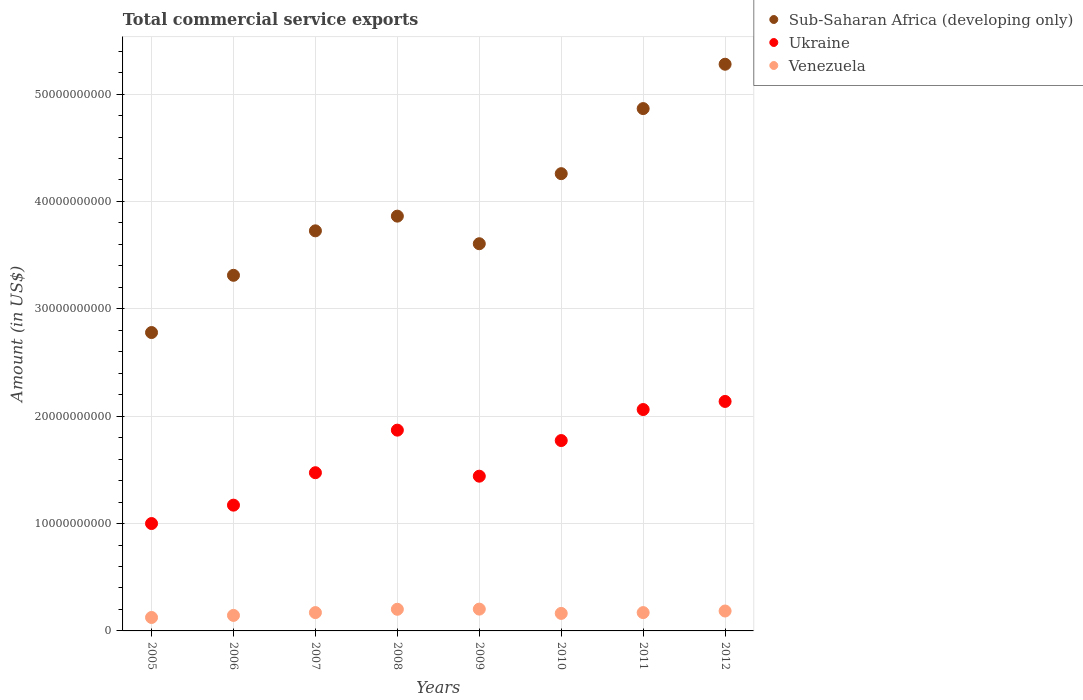What is the total commercial service exports in Sub-Saharan Africa (developing only) in 2011?
Your answer should be very brief. 4.86e+1. Across all years, what is the maximum total commercial service exports in Ukraine?
Keep it short and to the point. 2.14e+1. Across all years, what is the minimum total commercial service exports in Sub-Saharan Africa (developing only)?
Your response must be concise. 2.78e+1. In which year was the total commercial service exports in Venezuela minimum?
Give a very brief answer. 2005. What is the total total commercial service exports in Sub-Saharan Africa (developing only) in the graph?
Provide a succinct answer. 3.17e+11. What is the difference between the total commercial service exports in Ukraine in 2008 and that in 2011?
Your answer should be very brief. -1.92e+09. What is the difference between the total commercial service exports in Venezuela in 2011 and the total commercial service exports in Sub-Saharan Africa (developing only) in 2012?
Provide a succinct answer. -5.11e+1. What is the average total commercial service exports in Sub-Saharan Africa (developing only) per year?
Provide a short and direct response. 3.96e+1. In the year 2007, what is the difference between the total commercial service exports in Sub-Saharan Africa (developing only) and total commercial service exports in Venezuela?
Keep it short and to the point. 3.56e+1. In how many years, is the total commercial service exports in Ukraine greater than 40000000000 US$?
Keep it short and to the point. 0. What is the ratio of the total commercial service exports in Sub-Saharan Africa (developing only) in 2007 to that in 2009?
Your answer should be very brief. 1.03. Is the difference between the total commercial service exports in Sub-Saharan Africa (developing only) in 2006 and 2010 greater than the difference between the total commercial service exports in Venezuela in 2006 and 2010?
Provide a short and direct response. No. What is the difference between the highest and the second highest total commercial service exports in Sub-Saharan Africa (developing only)?
Ensure brevity in your answer.  4.13e+09. What is the difference between the highest and the lowest total commercial service exports in Sub-Saharan Africa (developing only)?
Provide a succinct answer. 2.50e+1. Is the total commercial service exports in Venezuela strictly less than the total commercial service exports in Sub-Saharan Africa (developing only) over the years?
Provide a short and direct response. Yes. How many dotlines are there?
Your answer should be very brief. 3. Are the values on the major ticks of Y-axis written in scientific E-notation?
Provide a succinct answer. No. Does the graph contain any zero values?
Ensure brevity in your answer.  No. Does the graph contain grids?
Offer a terse response. Yes. Where does the legend appear in the graph?
Your answer should be very brief. Top right. How are the legend labels stacked?
Make the answer very short. Vertical. What is the title of the graph?
Give a very brief answer. Total commercial service exports. Does "Eritrea" appear as one of the legend labels in the graph?
Keep it short and to the point. No. What is the label or title of the X-axis?
Your response must be concise. Years. What is the Amount (in US$) of Sub-Saharan Africa (developing only) in 2005?
Provide a succinct answer. 2.78e+1. What is the Amount (in US$) of Ukraine in 2005?
Ensure brevity in your answer.  1.00e+1. What is the Amount (in US$) in Venezuela in 2005?
Offer a terse response. 1.25e+09. What is the Amount (in US$) in Sub-Saharan Africa (developing only) in 2006?
Your answer should be compact. 3.31e+1. What is the Amount (in US$) of Ukraine in 2006?
Provide a succinct answer. 1.17e+1. What is the Amount (in US$) in Venezuela in 2006?
Give a very brief answer. 1.44e+09. What is the Amount (in US$) in Sub-Saharan Africa (developing only) in 2007?
Keep it short and to the point. 3.73e+1. What is the Amount (in US$) of Ukraine in 2007?
Your answer should be very brief. 1.47e+1. What is the Amount (in US$) of Venezuela in 2007?
Make the answer very short. 1.71e+09. What is the Amount (in US$) in Sub-Saharan Africa (developing only) in 2008?
Offer a very short reply. 3.86e+1. What is the Amount (in US$) in Ukraine in 2008?
Make the answer very short. 1.87e+1. What is the Amount (in US$) in Venezuela in 2008?
Make the answer very short. 2.02e+09. What is the Amount (in US$) of Sub-Saharan Africa (developing only) in 2009?
Your answer should be very brief. 3.61e+1. What is the Amount (in US$) in Ukraine in 2009?
Provide a short and direct response. 1.44e+1. What is the Amount (in US$) in Venezuela in 2009?
Keep it short and to the point. 2.03e+09. What is the Amount (in US$) in Sub-Saharan Africa (developing only) in 2010?
Ensure brevity in your answer.  4.26e+1. What is the Amount (in US$) in Ukraine in 2010?
Provide a succinct answer. 1.77e+1. What is the Amount (in US$) in Venezuela in 2010?
Provide a succinct answer. 1.63e+09. What is the Amount (in US$) in Sub-Saharan Africa (developing only) in 2011?
Make the answer very short. 4.86e+1. What is the Amount (in US$) of Ukraine in 2011?
Keep it short and to the point. 2.06e+1. What is the Amount (in US$) of Venezuela in 2011?
Offer a very short reply. 1.71e+09. What is the Amount (in US$) in Sub-Saharan Africa (developing only) in 2012?
Offer a terse response. 5.28e+1. What is the Amount (in US$) of Ukraine in 2012?
Provide a succinct answer. 2.14e+1. What is the Amount (in US$) of Venezuela in 2012?
Your answer should be very brief. 1.86e+09. Across all years, what is the maximum Amount (in US$) in Sub-Saharan Africa (developing only)?
Ensure brevity in your answer.  5.28e+1. Across all years, what is the maximum Amount (in US$) of Ukraine?
Provide a succinct answer. 2.14e+1. Across all years, what is the maximum Amount (in US$) in Venezuela?
Make the answer very short. 2.03e+09. Across all years, what is the minimum Amount (in US$) in Sub-Saharan Africa (developing only)?
Offer a very short reply. 2.78e+1. Across all years, what is the minimum Amount (in US$) of Ukraine?
Your answer should be compact. 1.00e+1. Across all years, what is the minimum Amount (in US$) in Venezuela?
Offer a very short reply. 1.25e+09. What is the total Amount (in US$) in Sub-Saharan Africa (developing only) in the graph?
Your answer should be very brief. 3.17e+11. What is the total Amount (in US$) of Ukraine in the graph?
Offer a very short reply. 1.29e+11. What is the total Amount (in US$) in Venezuela in the graph?
Your answer should be very brief. 1.36e+1. What is the difference between the Amount (in US$) of Sub-Saharan Africa (developing only) in 2005 and that in 2006?
Make the answer very short. -5.33e+09. What is the difference between the Amount (in US$) in Ukraine in 2005 and that in 2006?
Offer a terse response. -1.71e+09. What is the difference between the Amount (in US$) of Venezuela in 2005 and that in 2006?
Provide a succinct answer. -1.93e+08. What is the difference between the Amount (in US$) of Sub-Saharan Africa (developing only) in 2005 and that in 2007?
Give a very brief answer. -9.47e+09. What is the difference between the Amount (in US$) in Ukraine in 2005 and that in 2007?
Give a very brief answer. -4.73e+09. What is the difference between the Amount (in US$) of Venezuela in 2005 and that in 2007?
Keep it short and to the point. -4.55e+08. What is the difference between the Amount (in US$) of Sub-Saharan Africa (developing only) in 2005 and that in 2008?
Offer a terse response. -1.08e+1. What is the difference between the Amount (in US$) in Ukraine in 2005 and that in 2008?
Ensure brevity in your answer.  -8.70e+09. What is the difference between the Amount (in US$) of Venezuela in 2005 and that in 2008?
Offer a very short reply. -7.64e+08. What is the difference between the Amount (in US$) of Sub-Saharan Africa (developing only) in 2005 and that in 2009?
Offer a very short reply. -8.27e+09. What is the difference between the Amount (in US$) in Ukraine in 2005 and that in 2009?
Give a very brief answer. -4.41e+09. What is the difference between the Amount (in US$) of Venezuela in 2005 and that in 2009?
Your answer should be compact. -7.79e+08. What is the difference between the Amount (in US$) of Sub-Saharan Africa (developing only) in 2005 and that in 2010?
Keep it short and to the point. -1.48e+1. What is the difference between the Amount (in US$) in Ukraine in 2005 and that in 2010?
Provide a succinct answer. -7.73e+09. What is the difference between the Amount (in US$) in Venezuela in 2005 and that in 2010?
Your answer should be compact. -3.79e+08. What is the difference between the Amount (in US$) of Sub-Saharan Africa (developing only) in 2005 and that in 2011?
Your answer should be compact. -2.09e+1. What is the difference between the Amount (in US$) in Ukraine in 2005 and that in 2011?
Make the answer very short. -1.06e+1. What is the difference between the Amount (in US$) in Venezuela in 2005 and that in 2011?
Offer a very short reply. -4.54e+08. What is the difference between the Amount (in US$) of Sub-Saharan Africa (developing only) in 2005 and that in 2012?
Your answer should be very brief. -2.50e+1. What is the difference between the Amount (in US$) of Ukraine in 2005 and that in 2012?
Keep it short and to the point. -1.14e+1. What is the difference between the Amount (in US$) of Venezuela in 2005 and that in 2012?
Offer a very short reply. -6.03e+08. What is the difference between the Amount (in US$) in Sub-Saharan Africa (developing only) in 2006 and that in 2007?
Offer a very short reply. -4.14e+09. What is the difference between the Amount (in US$) of Ukraine in 2006 and that in 2007?
Your response must be concise. -3.02e+09. What is the difference between the Amount (in US$) of Venezuela in 2006 and that in 2007?
Keep it short and to the point. -2.62e+08. What is the difference between the Amount (in US$) of Sub-Saharan Africa (developing only) in 2006 and that in 2008?
Make the answer very short. -5.51e+09. What is the difference between the Amount (in US$) of Ukraine in 2006 and that in 2008?
Provide a short and direct response. -6.99e+09. What is the difference between the Amount (in US$) in Venezuela in 2006 and that in 2008?
Ensure brevity in your answer.  -5.71e+08. What is the difference between the Amount (in US$) of Sub-Saharan Africa (developing only) in 2006 and that in 2009?
Ensure brevity in your answer.  -2.94e+09. What is the difference between the Amount (in US$) of Ukraine in 2006 and that in 2009?
Give a very brief answer. -2.70e+09. What is the difference between the Amount (in US$) of Venezuela in 2006 and that in 2009?
Provide a short and direct response. -5.86e+08. What is the difference between the Amount (in US$) in Sub-Saharan Africa (developing only) in 2006 and that in 2010?
Keep it short and to the point. -9.47e+09. What is the difference between the Amount (in US$) of Ukraine in 2006 and that in 2010?
Your response must be concise. -6.02e+09. What is the difference between the Amount (in US$) of Venezuela in 2006 and that in 2010?
Your response must be concise. -1.86e+08. What is the difference between the Amount (in US$) of Sub-Saharan Africa (developing only) in 2006 and that in 2011?
Make the answer very short. -1.55e+1. What is the difference between the Amount (in US$) of Ukraine in 2006 and that in 2011?
Give a very brief answer. -8.90e+09. What is the difference between the Amount (in US$) of Venezuela in 2006 and that in 2011?
Give a very brief answer. -2.61e+08. What is the difference between the Amount (in US$) of Sub-Saharan Africa (developing only) in 2006 and that in 2012?
Your answer should be very brief. -1.97e+1. What is the difference between the Amount (in US$) of Ukraine in 2006 and that in 2012?
Provide a short and direct response. -9.66e+09. What is the difference between the Amount (in US$) of Venezuela in 2006 and that in 2012?
Your response must be concise. -4.10e+08. What is the difference between the Amount (in US$) in Sub-Saharan Africa (developing only) in 2007 and that in 2008?
Your answer should be very brief. -1.37e+09. What is the difference between the Amount (in US$) in Ukraine in 2007 and that in 2008?
Your answer should be very brief. -3.96e+09. What is the difference between the Amount (in US$) of Venezuela in 2007 and that in 2008?
Make the answer very short. -3.09e+08. What is the difference between the Amount (in US$) in Sub-Saharan Africa (developing only) in 2007 and that in 2009?
Your response must be concise. 1.20e+09. What is the difference between the Amount (in US$) of Ukraine in 2007 and that in 2009?
Provide a short and direct response. 3.23e+08. What is the difference between the Amount (in US$) of Venezuela in 2007 and that in 2009?
Your answer should be compact. -3.24e+08. What is the difference between the Amount (in US$) in Sub-Saharan Africa (developing only) in 2007 and that in 2010?
Provide a short and direct response. -5.32e+09. What is the difference between the Amount (in US$) in Ukraine in 2007 and that in 2010?
Give a very brief answer. -3.00e+09. What is the difference between the Amount (in US$) of Venezuela in 2007 and that in 2010?
Offer a very short reply. 7.60e+07. What is the difference between the Amount (in US$) in Sub-Saharan Africa (developing only) in 2007 and that in 2011?
Provide a succinct answer. -1.14e+1. What is the difference between the Amount (in US$) in Ukraine in 2007 and that in 2011?
Provide a succinct answer. -5.88e+09. What is the difference between the Amount (in US$) in Venezuela in 2007 and that in 2011?
Your answer should be very brief. 1.00e+06. What is the difference between the Amount (in US$) in Sub-Saharan Africa (developing only) in 2007 and that in 2012?
Provide a succinct answer. -1.55e+1. What is the difference between the Amount (in US$) of Ukraine in 2007 and that in 2012?
Ensure brevity in your answer.  -6.64e+09. What is the difference between the Amount (in US$) of Venezuela in 2007 and that in 2012?
Keep it short and to the point. -1.48e+08. What is the difference between the Amount (in US$) of Sub-Saharan Africa (developing only) in 2008 and that in 2009?
Provide a short and direct response. 2.57e+09. What is the difference between the Amount (in US$) in Ukraine in 2008 and that in 2009?
Your answer should be very brief. 4.29e+09. What is the difference between the Amount (in US$) of Venezuela in 2008 and that in 2009?
Your response must be concise. -1.50e+07. What is the difference between the Amount (in US$) of Sub-Saharan Africa (developing only) in 2008 and that in 2010?
Your answer should be compact. -3.96e+09. What is the difference between the Amount (in US$) of Ukraine in 2008 and that in 2010?
Make the answer very short. 9.70e+08. What is the difference between the Amount (in US$) of Venezuela in 2008 and that in 2010?
Give a very brief answer. 3.85e+08. What is the difference between the Amount (in US$) of Sub-Saharan Africa (developing only) in 2008 and that in 2011?
Keep it short and to the point. -1.00e+1. What is the difference between the Amount (in US$) in Ukraine in 2008 and that in 2011?
Your response must be concise. -1.92e+09. What is the difference between the Amount (in US$) of Venezuela in 2008 and that in 2011?
Your response must be concise. 3.10e+08. What is the difference between the Amount (in US$) of Sub-Saharan Africa (developing only) in 2008 and that in 2012?
Your answer should be compact. -1.41e+1. What is the difference between the Amount (in US$) of Ukraine in 2008 and that in 2012?
Offer a very short reply. -2.67e+09. What is the difference between the Amount (in US$) of Venezuela in 2008 and that in 2012?
Your answer should be very brief. 1.61e+08. What is the difference between the Amount (in US$) of Sub-Saharan Africa (developing only) in 2009 and that in 2010?
Offer a very short reply. -6.53e+09. What is the difference between the Amount (in US$) in Ukraine in 2009 and that in 2010?
Provide a succinct answer. -3.32e+09. What is the difference between the Amount (in US$) in Venezuela in 2009 and that in 2010?
Keep it short and to the point. 4.00e+08. What is the difference between the Amount (in US$) in Sub-Saharan Africa (developing only) in 2009 and that in 2011?
Your answer should be very brief. -1.26e+1. What is the difference between the Amount (in US$) of Ukraine in 2009 and that in 2011?
Your answer should be very brief. -6.21e+09. What is the difference between the Amount (in US$) of Venezuela in 2009 and that in 2011?
Your answer should be very brief. 3.25e+08. What is the difference between the Amount (in US$) of Sub-Saharan Africa (developing only) in 2009 and that in 2012?
Keep it short and to the point. -1.67e+1. What is the difference between the Amount (in US$) in Ukraine in 2009 and that in 2012?
Provide a short and direct response. -6.96e+09. What is the difference between the Amount (in US$) in Venezuela in 2009 and that in 2012?
Your response must be concise. 1.76e+08. What is the difference between the Amount (in US$) in Sub-Saharan Africa (developing only) in 2010 and that in 2011?
Your answer should be very brief. -6.06e+09. What is the difference between the Amount (in US$) of Ukraine in 2010 and that in 2011?
Provide a succinct answer. -2.89e+09. What is the difference between the Amount (in US$) in Venezuela in 2010 and that in 2011?
Keep it short and to the point. -7.50e+07. What is the difference between the Amount (in US$) of Sub-Saharan Africa (developing only) in 2010 and that in 2012?
Provide a short and direct response. -1.02e+1. What is the difference between the Amount (in US$) of Ukraine in 2010 and that in 2012?
Keep it short and to the point. -3.64e+09. What is the difference between the Amount (in US$) in Venezuela in 2010 and that in 2012?
Provide a short and direct response. -2.24e+08. What is the difference between the Amount (in US$) in Sub-Saharan Africa (developing only) in 2011 and that in 2012?
Provide a succinct answer. -4.13e+09. What is the difference between the Amount (in US$) of Ukraine in 2011 and that in 2012?
Give a very brief answer. -7.55e+08. What is the difference between the Amount (in US$) of Venezuela in 2011 and that in 2012?
Your response must be concise. -1.49e+08. What is the difference between the Amount (in US$) of Sub-Saharan Africa (developing only) in 2005 and the Amount (in US$) of Ukraine in 2006?
Your answer should be compact. 1.61e+1. What is the difference between the Amount (in US$) of Sub-Saharan Africa (developing only) in 2005 and the Amount (in US$) of Venezuela in 2006?
Your answer should be very brief. 2.63e+1. What is the difference between the Amount (in US$) of Ukraine in 2005 and the Amount (in US$) of Venezuela in 2006?
Give a very brief answer. 8.56e+09. What is the difference between the Amount (in US$) in Sub-Saharan Africa (developing only) in 2005 and the Amount (in US$) in Ukraine in 2007?
Your answer should be compact. 1.31e+1. What is the difference between the Amount (in US$) in Sub-Saharan Africa (developing only) in 2005 and the Amount (in US$) in Venezuela in 2007?
Provide a succinct answer. 2.61e+1. What is the difference between the Amount (in US$) in Ukraine in 2005 and the Amount (in US$) in Venezuela in 2007?
Provide a short and direct response. 8.29e+09. What is the difference between the Amount (in US$) of Sub-Saharan Africa (developing only) in 2005 and the Amount (in US$) of Ukraine in 2008?
Provide a succinct answer. 9.09e+09. What is the difference between the Amount (in US$) in Sub-Saharan Africa (developing only) in 2005 and the Amount (in US$) in Venezuela in 2008?
Make the answer very short. 2.58e+1. What is the difference between the Amount (in US$) of Ukraine in 2005 and the Amount (in US$) of Venezuela in 2008?
Your answer should be compact. 7.98e+09. What is the difference between the Amount (in US$) in Sub-Saharan Africa (developing only) in 2005 and the Amount (in US$) in Ukraine in 2009?
Offer a terse response. 1.34e+1. What is the difference between the Amount (in US$) of Sub-Saharan Africa (developing only) in 2005 and the Amount (in US$) of Venezuela in 2009?
Keep it short and to the point. 2.58e+1. What is the difference between the Amount (in US$) of Ukraine in 2005 and the Amount (in US$) of Venezuela in 2009?
Ensure brevity in your answer.  7.97e+09. What is the difference between the Amount (in US$) of Sub-Saharan Africa (developing only) in 2005 and the Amount (in US$) of Ukraine in 2010?
Provide a succinct answer. 1.01e+1. What is the difference between the Amount (in US$) in Sub-Saharan Africa (developing only) in 2005 and the Amount (in US$) in Venezuela in 2010?
Your response must be concise. 2.62e+1. What is the difference between the Amount (in US$) in Ukraine in 2005 and the Amount (in US$) in Venezuela in 2010?
Provide a succinct answer. 8.37e+09. What is the difference between the Amount (in US$) of Sub-Saharan Africa (developing only) in 2005 and the Amount (in US$) of Ukraine in 2011?
Ensure brevity in your answer.  7.17e+09. What is the difference between the Amount (in US$) in Sub-Saharan Africa (developing only) in 2005 and the Amount (in US$) in Venezuela in 2011?
Offer a terse response. 2.61e+1. What is the difference between the Amount (in US$) of Ukraine in 2005 and the Amount (in US$) of Venezuela in 2011?
Your response must be concise. 8.30e+09. What is the difference between the Amount (in US$) in Sub-Saharan Africa (developing only) in 2005 and the Amount (in US$) in Ukraine in 2012?
Your answer should be compact. 6.42e+09. What is the difference between the Amount (in US$) of Sub-Saharan Africa (developing only) in 2005 and the Amount (in US$) of Venezuela in 2012?
Give a very brief answer. 2.59e+1. What is the difference between the Amount (in US$) in Ukraine in 2005 and the Amount (in US$) in Venezuela in 2012?
Provide a short and direct response. 8.15e+09. What is the difference between the Amount (in US$) in Sub-Saharan Africa (developing only) in 2006 and the Amount (in US$) in Ukraine in 2007?
Make the answer very short. 1.84e+1. What is the difference between the Amount (in US$) in Sub-Saharan Africa (developing only) in 2006 and the Amount (in US$) in Venezuela in 2007?
Offer a very short reply. 3.14e+1. What is the difference between the Amount (in US$) in Ukraine in 2006 and the Amount (in US$) in Venezuela in 2007?
Give a very brief answer. 1.00e+1. What is the difference between the Amount (in US$) of Sub-Saharan Africa (developing only) in 2006 and the Amount (in US$) of Ukraine in 2008?
Your answer should be compact. 1.44e+1. What is the difference between the Amount (in US$) of Sub-Saharan Africa (developing only) in 2006 and the Amount (in US$) of Venezuela in 2008?
Your answer should be very brief. 3.11e+1. What is the difference between the Amount (in US$) of Ukraine in 2006 and the Amount (in US$) of Venezuela in 2008?
Your answer should be compact. 9.70e+09. What is the difference between the Amount (in US$) of Sub-Saharan Africa (developing only) in 2006 and the Amount (in US$) of Ukraine in 2009?
Ensure brevity in your answer.  1.87e+1. What is the difference between the Amount (in US$) of Sub-Saharan Africa (developing only) in 2006 and the Amount (in US$) of Venezuela in 2009?
Make the answer very short. 3.11e+1. What is the difference between the Amount (in US$) in Ukraine in 2006 and the Amount (in US$) in Venezuela in 2009?
Provide a short and direct response. 9.68e+09. What is the difference between the Amount (in US$) in Sub-Saharan Africa (developing only) in 2006 and the Amount (in US$) in Ukraine in 2010?
Ensure brevity in your answer.  1.54e+1. What is the difference between the Amount (in US$) in Sub-Saharan Africa (developing only) in 2006 and the Amount (in US$) in Venezuela in 2010?
Offer a terse response. 3.15e+1. What is the difference between the Amount (in US$) of Ukraine in 2006 and the Amount (in US$) of Venezuela in 2010?
Provide a succinct answer. 1.01e+1. What is the difference between the Amount (in US$) in Sub-Saharan Africa (developing only) in 2006 and the Amount (in US$) in Ukraine in 2011?
Ensure brevity in your answer.  1.25e+1. What is the difference between the Amount (in US$) of Sub-Saharan Africa (developing only) in 2006 and the Amount (in US$) of Venezuela in 2011?
Your answer should be very brief. 3.14e+1. What is the difference between the Amount (in US$) in Ukraine in 2006 and the Amount (in US$) in Venezuela in 2011?
Offer a terse response. 1.00e+1. What is the difference between the Amount (in US$) of Sub-Saharan Africa (developing only) in 2006 and the Amount (in US$) of Ukraine in 2012?
Your response must be concise. 1.17e+1. What is the difference between the Amount (in US$) of Sub-Saharan Africa (developing only) in 2006 and the Amount (in US$) of Venezuela in 2012?
Your answer should be compact. 3.13e+1. What is the difference between the Amount (in US$) in Ukraine in 2006 and the Amount (in US$) in Venezuela in 2012?
Offer a very short reply. 9.86e+09. What is the difference between the Amount (in US$) in Sub-Saharan Africa (developing only) in 2007 and the Amount (in US$) in Ukraine in 2008?
Give a very brief answer. 1.86e+1. What is the difference between the Amount (in US$) of Sub-Saharan Africa (developing only) in 2007 and the Amount (in US$) of Venezuela in 2008?
Provide a short and direct response. 3.52e+1. What is the difference between the Amount (in US$) of Ukraine in 2007 and the Amount (in US$) of Venezuela in 2008?
Your answer should be compact. 1.27e+1. What is the difference between the Amount (in US$) of Sub-Saharan Africa (developing only) in 2007 and the Amount (in US$) of Ukraine in 2009?
Give a very brief answer. 2.29e+1. What is the difference between the Amount (in US$) of Sub-Saharan Africa (developing only) in 2007 and the Amount (in US$) of Venezuela in 2009?
Your answer should be compact. 3.52e+1. What is the difference between the Amount (in US$) of Ukraine in 2007 and the Amount (in US$) of Venezuela in 2009?
Make the answer very short. 1.27e+1. What is the difference between the Amount (in US$) of Sub-Saharan Africa (developing only) in 2007 and the Amount (in US$) of Ukraine in 2010?
Provide a short and direct response. 1.95e+1. What is the difference between the Amount (in US$) in Sub-Saharan Africa (developing only) in 2007 and the Amount (in US$) in Venezuela in 2010?
Provide a short and direct response. 3.56e+1. What is the difference between the Amount (in US$) of Ukraine in 2007 and the Amount (in US$) of Venezuela in 2010?
Ensure brevity in your answer.  1.31e+1. What is the difference between the Amount (in US$) of Sub-Saharan Africa (developing only) in 2007 and the Amount (in US$) of Ukraine in 2011?
Your response must be concise. 1.66e+1. What is the difference between the Amount (in US$) in Sub-Saharan Africa (developing only) in 2007 and the Amount (in US$) in Venezuela in 2011?
Your response must be concise. 3.56e+1. What is the difference between the Amount (in US$) in Ukraine in 2007 and the Amount (in US$) in Venezuela in 2011?
Provide a short and direct response. 1.30e+1. What is the difference between the Amount (in US$) of Sub-Saharan Africa (developing only) in 2007 and the Amount (in US$) of Ukraine in 2012?
Your answer should be compact. 1.59e+1. What is the difference between the Amount (in US$) in Sub-Saharan Africa (developing only) in 2007 and the Amount (in US$) in Venezuela in 2012?
Make the answer very short. 3.54e+1. What is the difference between the Amount (in US$) of Ukraine in 2007 and the Amount (in US$) of Venezuela in 2012?
Offer a very short reply. 1.29e+1. What is the difference between the Amount (in US$) in Sub-Saharan Africa (developing only) in 2008 and the Amount (in US$) in Ukraine in 2009?
Provide a short and direct response. 2.42e+1. What is the difference between the Amount (in US$) in Sub-Saharan Africa (developing only) in 2008 and the Amount (in US$) in Venezuela in 2009?
Ensure brevity in your answer.  3.66e+1. What is the difference between the Amount (in US$) of Ukraine in 2008 and the Amount (in US$) of Venezuela in 2009?
Provide a short and direct response. 1.67e+1. What is the difference between the Amount (in US$) in Sub-Saharan Africa (developing only) in 2008 and the Amount (in US$) in Ukraine in 2010?
Offer a terse response. 2.09e+1. What is the difference between the Amount (in US$) of Sub-Saharan Africa (developing only) in 2008 and the Amount (in US$) of Venezuela in 2010?
Your answer should be very brief. 3.70e+1. What is the difference between the Amount (in US$) of Ukraine in 2008 and the Amount (in US$) of Venezuela in 2010?
Give a very brief answer. 1.71e+1. What is the difference between the Amount (in US$) of Sub-Saharan Africa (developing only) in 2008 and the Amount (in US$) of Ukraine in 2011?
Give a very brief answer. 1.80e+1. What is the difference between the Amount (in US$) in Sub-Saharan Africa (developing only) in 2008 and the Amount (in US$) in Venezuela in 2011?
Your answer should be very brief. 3.69e+1. What is the difference between the Amount (in US$) of Ukraine in 2008 and the Amount (in US$) of Venezuela in 2011?
Offer a terse response. 1.70e+1. What is the difference between the Amount (in US$) of Sub-Saharan Africa (developing only) in 2008 and the Amount (in US$) of Ukraine in 2012?
Ensure brevity in your answer.  1.73e+1. What is the difference between the Amount (in US$) in Sub-Saharan Africa (developing only) in 2008 and the Amount (in US$) in Venezuela in 2012?
Offer a very short reply. 3.68e+1. What is the difference between the Amount (in US$) in Ukraine in 2008 and the Amount (in US$) in Venezuela in 2012?
Offer a terse response. 1.68e+1. What is the difference between the Amount (in US$) of Sub-Saharan Africa (developing only) in 2009 and the Amount (in US$) of Ukraine in 2010?
Provide a short and direct response. 1.83e+1. What is the difference between the Amount (in US$) of Sub-Saharan Africa (developing only) in 2009 and the Amount (in US$) of Venezuela in 2010?
Keep it short and to the point. 3.44e+1. What is the difference between the Amount (in US$) in Ukraine in 2009 and the Amount (in US$) in Venezuela in 2010?
Your answer should be very brief. 1.28e+1. What is the difference between the Amount (in US$) in Sub-Saharan Africa (developing only) in 2009 and the Amount (in US$) in Ukraine in 2011?
Your response must be concise. 1.54e+1. What is the difference between the Amount (in US$) in Sub-Saharan Africa (developing only) in 2009 and the Amount (in US$) in Venezuela in 2011?
Provide a succinct answer. 3.44e+1. What is the difference between the Amount (in US$) of Ukraine in 2009 and the Amount (in US$) of Venezuela in 2011?
Offer a very short reply. 1.27e+1. What is the difference between the Amount (in US$) of Sub-Saharan Africa (developing only) in 2009 and the Amount (in US$) of Ukraine in 2012?
Your response must be concise. 1.47e+1. What is the difference between the Amount (in US$) of Sub-Saharan Africa (developing only) in 2009 and the Amount (in US$) of Venezuela in 2012?
Your answer should be very brief. 3.42e+1. What is the difference between the Amount (in US$) in Ukraine in 2009 and the Amount (in US$) in Venezuela in 2012?
Your answer should be compact. 1.26e+1. What is the difference between the Amount (in US$) in Sub-Saharan Africa (developing only) in 2010 and the Amount (in US$) in Ukraine in 2011?
Provide a succinct answer. 2.20e+1. What is the difference between the Amount (in US$) in Sub-Saharan Africa (developing only) in 2010 and the Amount (in US$) in Venezuela in 2011?
Make the answer very short. 4.09e+1. What is the difference between the Amount (in US$) in Ukraine in 2010 and the Amount (in US$) in Venezuela in 2011?
Provide a succinct answer. 1.60e+1. What is the difference between the Amount (in US$) in Sub-Saharan Africa (developing only) in 2010 and the Amount (in US$) in Ukraine in 2012?
Provide a succinct answer. 2.12e+1. What is the difference between the Amount (in US$) in Sub-Saharan Africa (developing only) in 2010 and the Amount (in US$) in Venezuela in 2012?
Give a very brief answer. 4.07e+1. What is the difference between the Amount (in US$) in Ukraine in 2010 and the Amount (in US$) in Venezuela in 2012?
Provide a short and direct response. 1.59e+1. What is the difference between the Amount (in US$) in Sub-Saharan Africa (developing only) in 2011 and the Amount (in US$) in Ukraine in 2012?
Provide a short and direct response. 2.73e+1. What is the difference between the Amount (in US$) in Sub-Saharan Africa (developing only) in 2011 and the Amount (in US$) in Venezuela in 2012?
Give a very brief answer. 4.68e+1. What is the difference between the Amount (in US$) in Ukraine in 2011 and the Amount (in US$) in Venezuela in 2012?
Your answer should be compact. 1.88e+1. What is the average Amount (in US$) in Sub-Saharan Africa (developing only) per year?
Offer a very short reply. 3.96e+1. What is the average Amount (in US$) of Ukraine per year?
Give a very brief answer. 1.62e+1. What is the average Amount (in US$) of Venezuela per year?
Make the answer very short. 1.71e+09. In the year 2005, what is the difference between the Amount (in US$) of Sub-Saharan Africa (developing only) and Amount (in US$) of Ukraine?
Offer a terse response. 1.78e+1. In the year 2005, what is the difference between the Amount (in US$) of Sub-Saharan Africa (developing only) and Amount (in US$) of Venezuela?
Keep it short and to the point. 2.65e+1. In the year 2005, what is the difference between the Amount (in US$) of Ukraine and Amount (in US$) of Venezuela?
Your answer should be very brief. 8.75e+09. In the year 2006, what is the difference between the Amount (in US$) in Sub-Saharan Africa (developing only) and Amount (in US$) in Ukraine?
Make the answer very short. 2.14e+1. In the year 2006, what is the difference between the Amount (in US$) of Sub-Saharan Africa (developing only) and Amount (in US$) of Venezuela?
Provide a short and direct response. 3.17e+1. In the year 2006, what is the difference between the Amount (in US$) in Ukraine and Amount (in US$) in Venezuela?
Provide a short and direct response. 1.03e+1. In the year 2007, what is the difference between the Amount (in US$) of Sub-Saharan Africa (developing only) and Amount (in US$) of Ukraine?
Give a very brief answer. 2.25e+1. In the year 2007, what is the difference between the Amount (in US$) of Sub-Saharan Africa (developing only) and Amount (in US$) of Venezuela?
Ensure brevity in your answer.  3.56e+1. In the year 2007, what is the difference between the Amount (in US$) in Ukraine and Amount (in US$) in Venezuela?
Your answer should be compact. 1.30e+1. In the year 2008, what is the difference between the Amount (in US$) of Sub-Saharan Africa (developing only) and Amount (in US$) of Ukraine?
Provide a short and direct response. 1.99e+1. In the year 2008, what is the difference between the Amount (in US$) of Sub-Saharan Africa (developing only) and Amount (in US$) of Venezuela?
Provide a short and direct response. 3.66e+1. In the year 2008, what is the difference between the Amount (in US$) in Ukraine and Amount (in US$) in Venezuela?
Give a very brief answer. 1.67e+1. In the year 2009, what is the difference between the Amount (in US$) in Sub-Saharan Africa (developing only) and Amount (in US$) in Ukraine?
Offer a very short reply. 2.16e+1. In the year 2009, what is the difference between the Amount (in US$) of Sub-Saharan Africa (developing only) and Amount (in US$) of Venezuela?
Offer a very short reply. 3.40e+1. In the year 2009, what is the difference between the Amount (in US$) of Ukraine and Amount (in US$) of Venezuela?
Offer a very short reply. 1.24e+1. In the year 2010, what is the difference between the Amount (in US$) of Sub-Saharan Africa (developing only) and Amount (in US$) of Ukraine?
Offer a very short reply. 2.49e+1. In the year 2010, what is the difference between the Amount (in US$) of Sub-Saharan Africa (developing only) and Amount (in US$) of Venezuela?
Provide a short and direct response. 4.10e+1. In the year 2010, what is the difference between the Amount (in US$) in Ukraine and Amount (in US$) in Venezuela?
Offer a terse response. 1.61e+1. In the year 2011, what is the difference between the Amount (in US$) in Sub-Saharan Africa (developing only) and Amount (in US$) in Ukraine?
Offer a very short reply. 2.80e+1. In the year 2011, what is the difference between the Amount (in US$) in Sub-Saharan Africa (developing only) and Amount (in US$) in Venezuela?
Give a very brief answer. 4.69e+1. In the year 2011, what is the difference between the Amount (in US$) in Ukraine and Amount (in US$) in Venezuela?
Keep it short and to the point. 1.89e+1. In the year 2012, what is the difference between the Amount (in US$) of Sub-Saharan Africa (developing only) and Amount (in US$) of Ukraine?
Offer a very short reply. 3.14e+1. In the year 2012, what is the difference between the Amount (in US$) of Sub-Saharan Africa (developing only) and Amount (in US$) of Venezuela?
Provide a short and direct response. 5.09e+1. In the year 2012, what is the difference between the Amount (in US$) of Ukraine and Amount (in US$) of Venezuela?
Your answer should be compact. 1.95e+1. What is the ratio of the Amount (in US$) of Sub-Saharan Africa (developing only) in 2005 to that in 2006?
Make the answer very short. 0.84. What is the ratio of the Amount (in US$) in Ukraine in 2005 to that in 2006?
Your answer should be compact. 0.85. What is the ratio of the Amount (in US$) of Venezuela in 2005 to that in 2006?
Give a very brief answer. 0.87. What is the ratio of the Amount (in US$) of Sub-Saharan Africa (developing only) in 2005 to that in 2007?
Your answer should be very brief. 0.75. What is the ratio of the Amount (in US$) of Ukraine in 2005 to that in 2007?
Provide a succinct answer. 0.68. What is the ratio of the Amount (in US$) in Venezuela in 2005 to that in 2007?
Your response must be concise. 0.73. What is the ratio of the Amount (in US$) in Sub-Saharan Africa (developing only) in 2005 to that in 2008?
Make the answer very short. 0.72. What is the ratio of the Amount (in US$) of Ukraine in 2005 to that in 2008?
Your answer should be compact. 0.53. What is the ratio of the Amount (in US$) in Venezuela in 2005 to that in 2008?
Your answer should be compact. 0.62. What is the ratio of the Amount (in US$) in Sub-Saharan Africa (developing only) in 2005 to that in 2009?
Keep it short and to the point. 0.77. What is the ratio of the Amount (in US$) in Ukraine in 2005 to that in 2009?
Make the answer very short. 0.69. What is the ratio of the Amount (in US$) of Venezuela in 2005 to that in 2009?
Your response must be concise. 0.62. What is the ratio of the Amount (in US$) in Sub-Saharan Africa (developing only) in 2005 to that in 2010?
Give a very brief answer. 0.65. What is the ratio of the Amount (in US$) of Ukraine in 2005 to that in 2010?
Offer a terse response. 0.56. What is the ratio of the Amount (in US$) of Venezuela in 2005 to that in 2010?
Give a very brief answer. 0.77. What is the ratio of the Amount (in US$) in Sub-Saharan Africa (developing only) in 2005 to that in 2011?
Provide a succinct answer. 0.57. What is the ratio of the Amount (in US$) of Ukraine in 2005 to that in 2011?
Keep it short and to the point. 0.49. What is the ratio of the Amount (in US$) of Venezuela in 2005 to that in 2011?
Offer a very short reply. 0.73. What is the ratio of the Amount (in US$) of Sub-Saharan Africa (developing only) in 2005 to that in 2012?
Your answer should be compact. 0.53. What is the ratio of the Amount (in US$) in Ukraine in 2005 to that in 2012?
Make the answer very short. 0.47. What is the ratio of the Amount (in US$) of Venezuela in 2005 to that in 2012?
Offer a very short reply. 0.67. What is the ratio of the Amount (in US$) in Sub-Saharan Africa (developing only) in 2006 to that in 2007?
Your response must be concise. 0.89. What is the ratio of the Amount (in US$) of Ukraine in 2006 to that in 2007?
Make the answer very short. 0.8. What is the ratio of the Amount (in US$) of Venezuela in 2006 to that in 2007?
Keep it short and to the point. 0.85. What is the ratio of the Amount (in US$) of Sub-Saharan Africa (developing only) in 2006 to that in 2008?
Offer a very short reply. 0.86. What is the ratio of the Amount (in US$) of Ukraine in 2006 to that in 2008?
Your answer should be compact. 0.63. What is the ratio of the Amount (in US$) in Venezuela in 2006 to that in 2008?
Offer a very short reply. 0.72. What is the ratio of the Amount (in US$) in Sub-Saharan Africa (developing only) in 2006 to that in 2009?
Give a very brief answer. 0.92. What is the ratio of the Amount (in US$) of Ukraine in 2006 to that in 2009?
Your response must be concise. 0.81. What is the ratio of the Amount (in US$) of Venezuela in 2006 to that in 2009?
Your answer should be compact. 0.71. What is the ratio of the Amount (in US$) in Sub-Saharan Africa (developing only) in 2006 to that in 2010?
Give a very brief answer. 0.78. What is the ratio of the Amount (in US$) in Ukraine in 2006 to that in 2010?
Your response must be concise. 0.66. What is the ratio of the Amount (in US$) of Venezuela in 2006 to that in 2010?
Your answer should be compact. 0.89. What is the ratio of the Amount (in US$) in Sub-Saharan Africa (developing only) in 2006 to that in 2011?
Make the answer very short. 0.68. What is the ratio of the Amount (in US$) of Ukraine in 2006 to that in 2011?
Ensure brevity in your answer.  0.57. What is the ratio of the Amount (in US$) of Venezuela in 2006 to that in 2011?
Provide a short and direct response. 0.85. What is the ratio of the Amount (in US$) of Sub-Saharan Africa (developing only) in 2006 to that in 2012?
Your response must be concise. 0.63. What is the ratio of the Amount (in US$) in Ukraine in 2006 to that in 2012?
Your answer should be compact. 0.55. What is the ratio of the Amount (in US$) in Venezuela in 2006 to that in 2012?
Your answer should be compact. 0.78. What is the ratio of the Amount (in US$) of Sub-Saharan Africa (developing only) in 2007 to that in 2008?
Offer a very short reply. 0.96. What is the ratio of the Amount (in US$) in Ukraine in 2007 to that in 2008?
Provide a succinct answer. 0.79. What is the ratio of the Amount (in US$) of Venezuela in 2007 to that in 2008?
Ensure brevity in your answer.  0.85. What is the ratio of the Amount (in US$) in Sub-Saharan Africa (developing only) in 2007 to that in 2009?
Provide a succinct answer. 1.03. What is the ratio of the Amount (in US$) in Ukraine in 2007 to that in 2009?
Offer a very short reply. 1.02. What is the ratio of the Amount (in US$) of Venezuela in 2007 to that in 2009?
Make the answer very short. 0.84. What is the ratio of the Amount (in US$) in Ukraine in 2007 to that in 2010?
Your response must be concise. 0.83. What is the ratio of the Amount (in US$) in Venezuela in 2007 to that in 2010?
Provide a succinct answer. 1.05. What is the ratio of the Amount (in US$) of Sub-Saharan Africa (developing only) in 2007 to that in 2011?
Make the answer very short. 0.77. What is the ratio of the Amount (in US$) in Ukraine in 2007 to that in 2011?
Your answer should be compact. 0.71. What is the ratio of the Amount (in US$) in Venezuela in 2007 to that in 2011?
Your answer should be very brief. 1. What is the ratio of the Amount (in US$) in Sub-Saharan Africa (developing only) in 2007 to that in 2012?
Give a very brief answer. 0.71. What is the ratio of the Amount (in US$) of Ukraine in 2007 to that in 2012?
Provide a succinct answer. 0.69. What is the ratio of the Amount (in US$) of Venezuela in 2007 to that in 2012?
Keep it short and to the point. 0.92. What is the ratio of the Amount (in US$) in Sub-Saharan Africa (developing only) in 2008 to that in 2009?
Keep it short and to the point. 1.07. What is the ratio of the Amount (in US$) in Ukraine in 2008 to that in 2009?
Provide a succinct answer. 1.3. What is the ratio of the Amount (in US$) in Sub-Saharan Africa (developing only) in 2008 to that in 2010?
Keep it short and to the point. 0.91. What is the ratio of the Amount (in US$) in Ukraine in 2008 to that in 2010?
Your response must be concise. 1.05. What is the ratio of the Amount (in US$) in Venezuela in 2008 to that in 2010?
Provide a succinct answer. 1.24. What is the ratio of the Amount (in US$) of Sub-Saharan Africa (developing only) in 2008 to that in 2011?
Provide a short and direct response. 0.79. What is the ratio of the Amount (in US$) of Ukraine in 2008 to that in 2011?
Your response must be concise. 0.91. What is the ratio of the Amount (in US$) in Venezuela in 2008 to that in 2011?
Your response must be concise. 1.18. What is the ratio of the Amount (in US$) in Sub-Saharan Africa (developing only) in 2008 to that in 2012?
Your answer should be very brief. 0.73. What is the ratio of the Amount (in US$) in Ukraine in 2008 to that in 2012?
Your answer should be compact. 0.87. What is the ratio of the Amount (in US$) in Venezuela in 2008 to that in 2012?
Your response must be concise. 1.09. What is the ratio of the Amount (in US$) in Sub-Saharan Africa (developing only) in 2009 to that in 2010?
Keep it short and to the point. 0.85. What is the ratio of the Amount (in US$) of Ukraine in 2009 to that in 2010?
Give a very brief answer. 0.81. What is the ratio of the Amount (in US$) in Venezuela in 2009 to that in 2010?
Make the answer very short. 1.25. What is the ratio of the Amount (in US$) of Sub-Saharan Africa (developing only) in 2009 to that in 2011?
Provide a succinct answer. 0.74. What is the ratio of the Amount (in US$) of Ukraine in 2009 to that in 2011?
Give a very brief answer. 0.7. What is the ratio of the Amount (in US$) of Venezuela in 2009 to that in 2011?
Offer a terse response. 1.19. What is the ratio of the Amount (in US$) of Sub-Saharan Africa (developing only) in 2009 to that in 2012?
Ensure brevity in your answer.  0.68. What is the ratio of the Amount (in US$) in Ukraine in 2009 to that in 2012?
Your answer should be compact. 0.67. What is the ratio of the Amount (in US$) of Venezuela in 2009 to that in 2012?
Give a very brief answer. 1.09. What is the ratio of the Amount (in US$) of Sub-Saharan Africa (developing only) in 2010 to that in 2011?
Give a very brief answer. 0.88. What is the ratio of the Amount (in US$) in Ukraine in 2010 to that in 2011?
Give a very brief answer. 0.86. What is the ratio of the Amount (in US$) in Venezuela in 2010 to that in 2011?
Your answer should be very brief. 0.96. What is the ratio of the Amount (in US$) of Sub-Saharan Africa (developing only) in 2010 to that in 2012?
Ensure brevity in your answer.  0.81. What is the ratio of the Amount (in US$) in Ukraine in 2010 to that in 2012?
Keep it short and to the point. 0.83. What is the ratio of the Amount (in US$) in Venezuela in 2010 to that in 2012?
Your answer should be very brief. 0.88. What is the ratio of the Amount (in US$) of Sub-Saharan Africa (developing only) in 2011 to that in 2012?
Your response must be concise. 0.92. What is the ratio of the Amount (in US$) in Ukraine in 2011 to that in 2012?
Your response must be concise. 0.96. What is the ratio of the Amount (in US$) in Venezuela in 2011 to that in 2012?
Provide a succinct answer. 0.92. What is the difference between the highest and the second highest Amount (in US$) in Sub-Saharan Africa (developing only)?
Offer a terse response. 4.13e+09. What is the difference between the highest and the second highest Amount (in US$) in Ukraine?
Offer a terse response. 7.55e+08. What is the difference between the highest and the second highest Amount (in US$) in Venezuela?
Provide a short and direct response. 1.50e+07. What is the difference between the highest and the lowest Amount (in US$) of Sub-Saharan Africa (developing only)?
Your answer should be compact. 2.50e+1. What is the difference between the highest and the lowest Amount (in US$) in Ukraine?
Offer a terse response. 1.14e+1. What is the difference between the highest and the lowest Amount (in US$) in Venezuela?
Provide a short and direct response. 7.79e+08. 